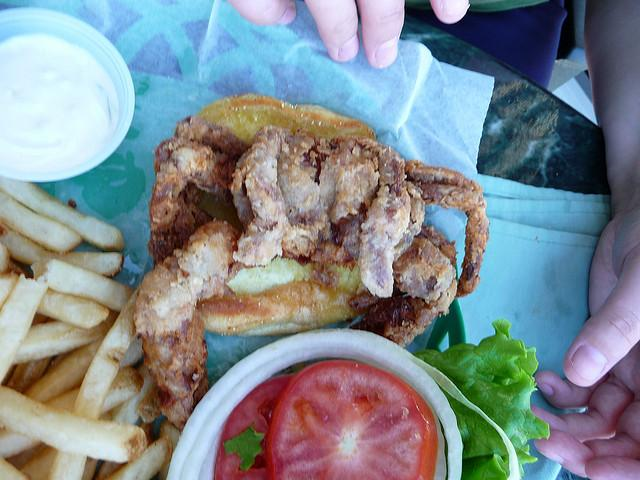What is being dissected here?

Choices:
A) machine
B) sandwich
C) frog
D) table sandwich 